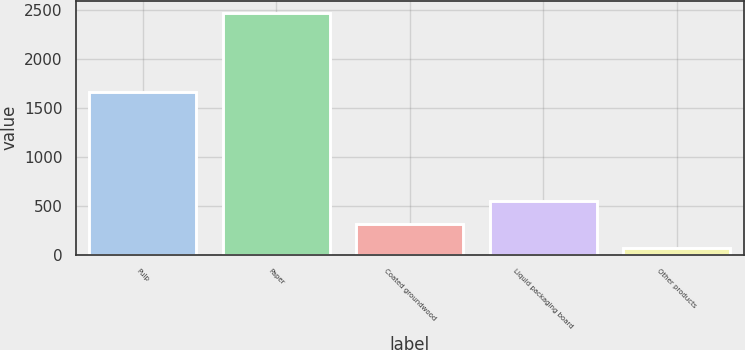<chart> <loc_0><loc_0><loc_500><loc_500><bar_chart><fcel>Pulp<fcel>Paper<fcel>Coated groundwood<fcel>Liquid packaging board<fcel>Other products<nl><fcel>1657<fcel>2470<fcel>313.6<fcel>553.2<fcel>74<nl></chart> 